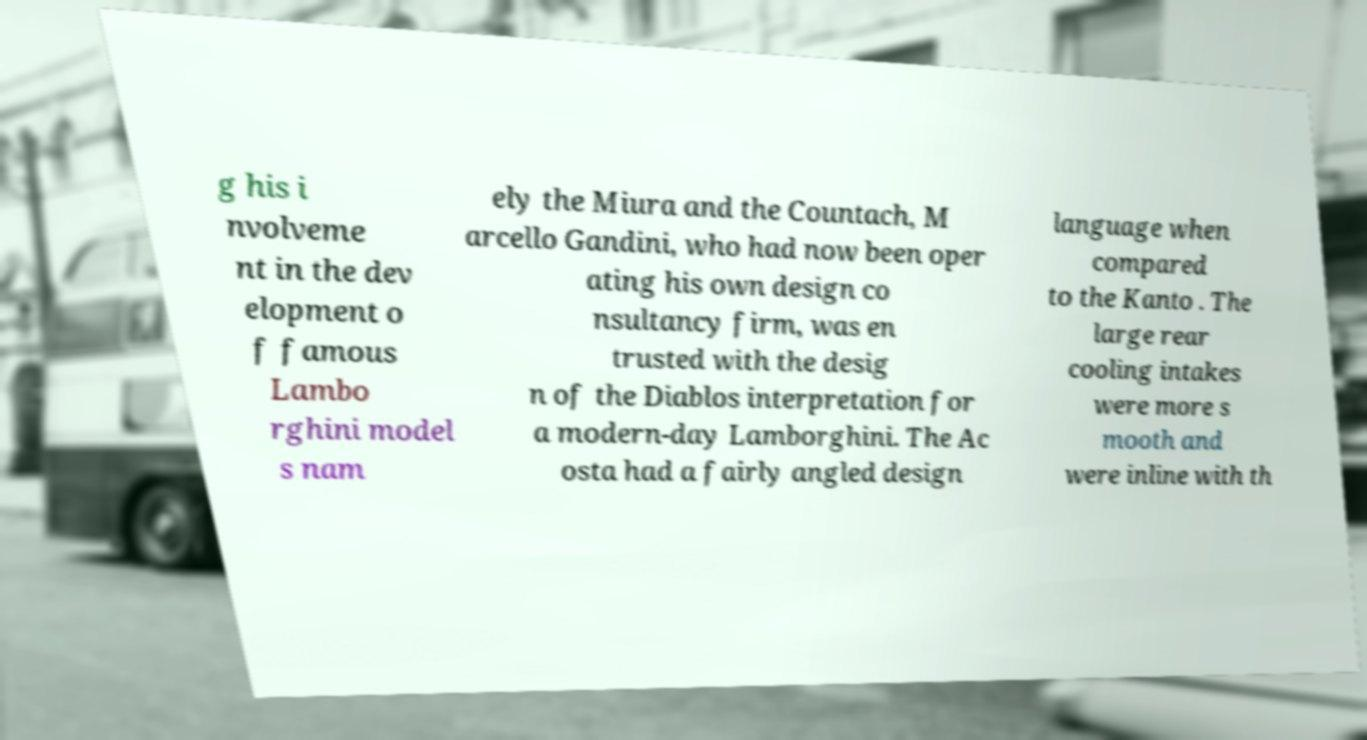Please identify and transcribe the text found in this image. g his i nvolveme nt in the dev elopment o f famous Lambo rghini model s nam ely the Miura and the Countach, M arcello Gandini, who had now been oper ating his own design co nsultancy firm, was en trusted with the desig n of the Diablos interpretation for a modern-day Lamborghini. The Ac osta had a fairly angled design language when compared to the Kanto . The large rear cooling intakes were more s mooth and were inline with th 